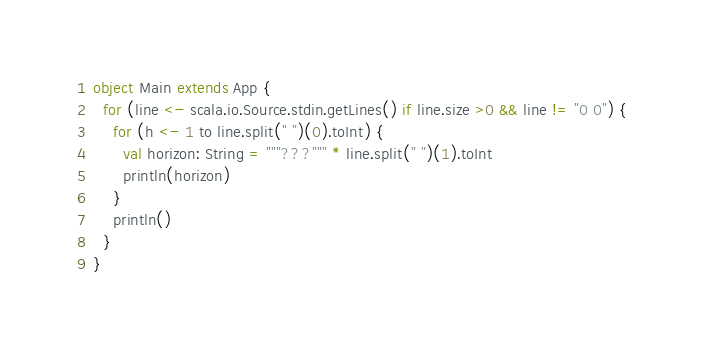<code> <loc_0><loc_0><loc_500><loc_500><_Scala_>object Main extends App {
  for (line <- scala.io.Source.stdin.getLines() if line.size >0 && line != "0 0") {
    for (h <- 1 to line.split(" ")(0).toInt) {
      val horizon: String = """???""" * line.split(" ")(1).toInt
      println(horizon)
    }
    println()
  }
}</code> 